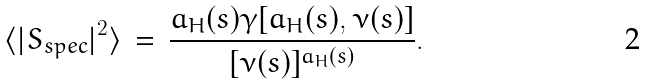<formula> <loc_0><loc_0><loc_500><loc_500>\langle { | S _ { s p e c } | } ^ { 2 } \rangle \, = \, \frac { a _ { H } ( s ) \gamma [ a _ { H } ( s ) , \nu ( s ) ] } { [ \nu ( s ) ] ^ { a _ { H } ( s ) } } .</formula> 